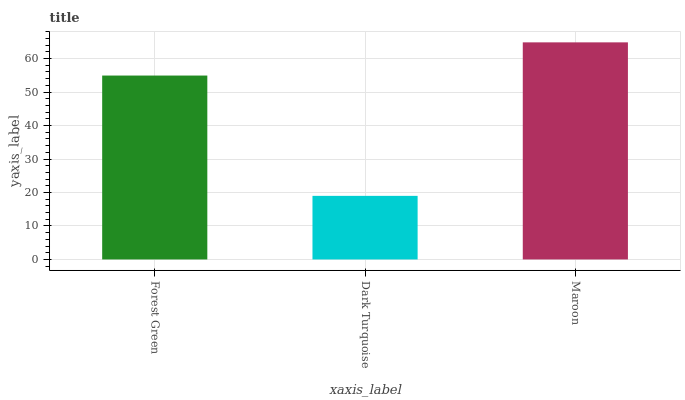Is Dark Turquoise the minimum?
Answer yes or no. Yes. Is Maroon the maximum?
Answer yes or no. Yes. Is Maroon the minimum?
Answer yes or no. No. Is Dark Turquoise the maximum?
Answer yes or no. No. Is Maroon greater than Dark Turquoise?
Answer yes or no. Yes. Is Dark Turquoise less than Maroon?
Answer yes or no. Yes. Is Dark Turquoise greater than Maroon?
Answer yes or no. No. Is Maroon less than Dark Turquoise?
Answer yes or no. No. Is Forest Green the high median?
Answer yes or no. Yes. Is Forest Green the low median?
Answer yes or no. Yes. Is Dark Turquoise the high median?
Answer yes or no. No. Is Dark Turquoise the low median?
Answer yes or no. No. 